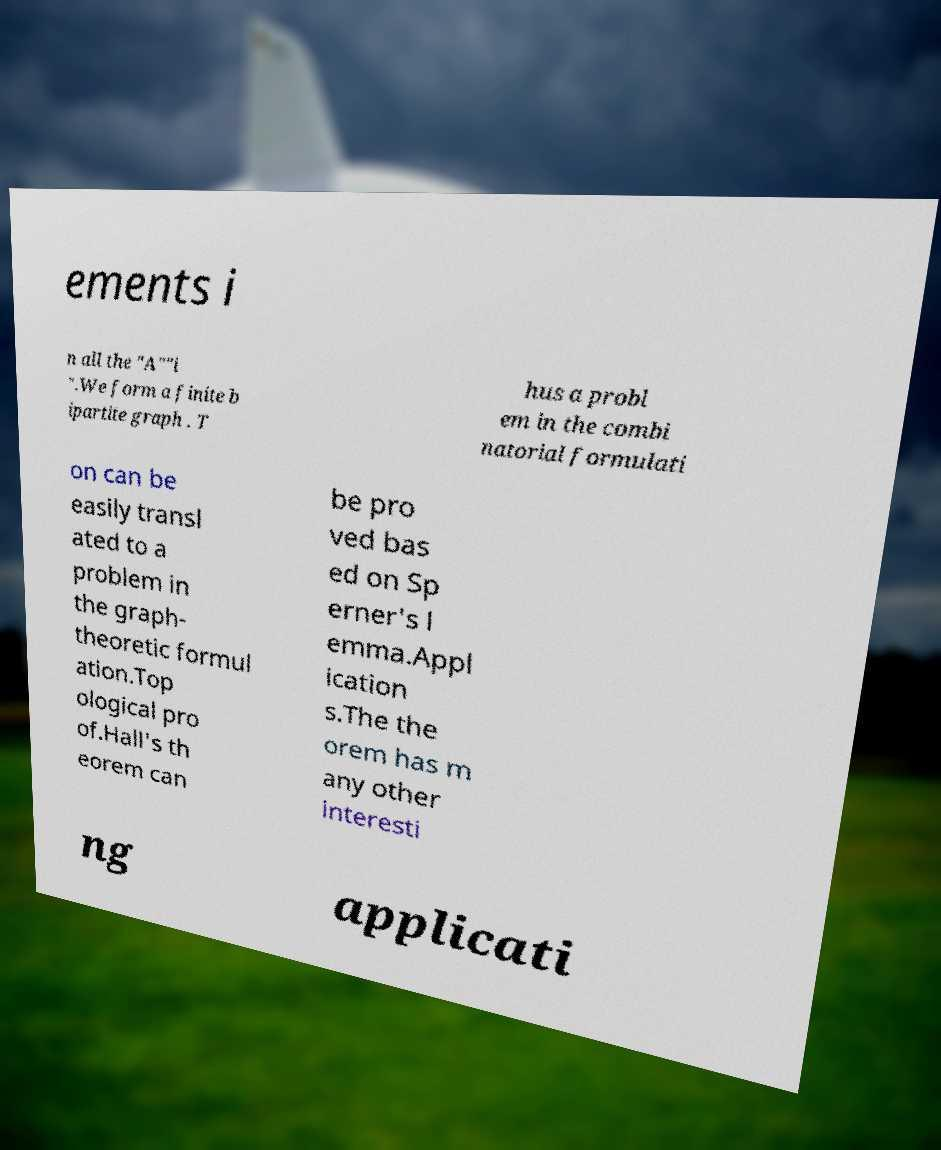Could you assist in decoding the text presented in this image and type it out clearly? ements i n all the "A""i ".We form a finite b ipartite graph . T hus a probl em in the combi natorial formulati on can be easily transl ated to a problem in the graph- theoretic formul ation.Top ological pro of.Hall's th eorem can be pro ved bas ed on Sp erner's l emma.Appl ication s.The the orem has m any other interesti ng applicati 